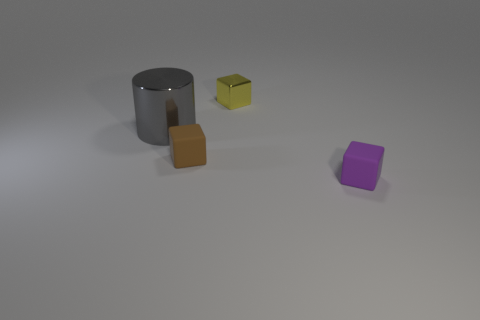What number of tiny matte cubes are the same color as the cylinder?
Offer a very short reply. 0. There is a metal object that is on the right side of the gray thing; does it have the same shape as the big object to the left of the brown matte cube?
Offer a very short reply. No. The thing that is right of the metal thing on the right side of the small thing that is left of the yellow cube is what color?
Your answer should be very brief. Purple. The metal object in front of the metal block is what color?
Your response must be concise. Gray. What is the color of the rubber thing that is the same size as the purple cube?
Keep it short and to the point. Brown. Do the metal cylinder and the purple rubber block have the same size?
Your response must be concise. No. How many small yellow cubes are on the right side of the tiny purple object?
Give a very brief answer. 0. What number of objects are tiny cubes behind the purple matte object or small purple rubber things?
Give a very brief answer. 3. Is the number of objects behind the large cylinder greater than the number of tiny yellow shiny things in front of the tiny yellow metal thing?
Your answer should be very brief. Yes. There is a yellow metallic cube; is it the same size as the rubber block to the right of the brown matte cube?
Your answer should be compact. Yes. 